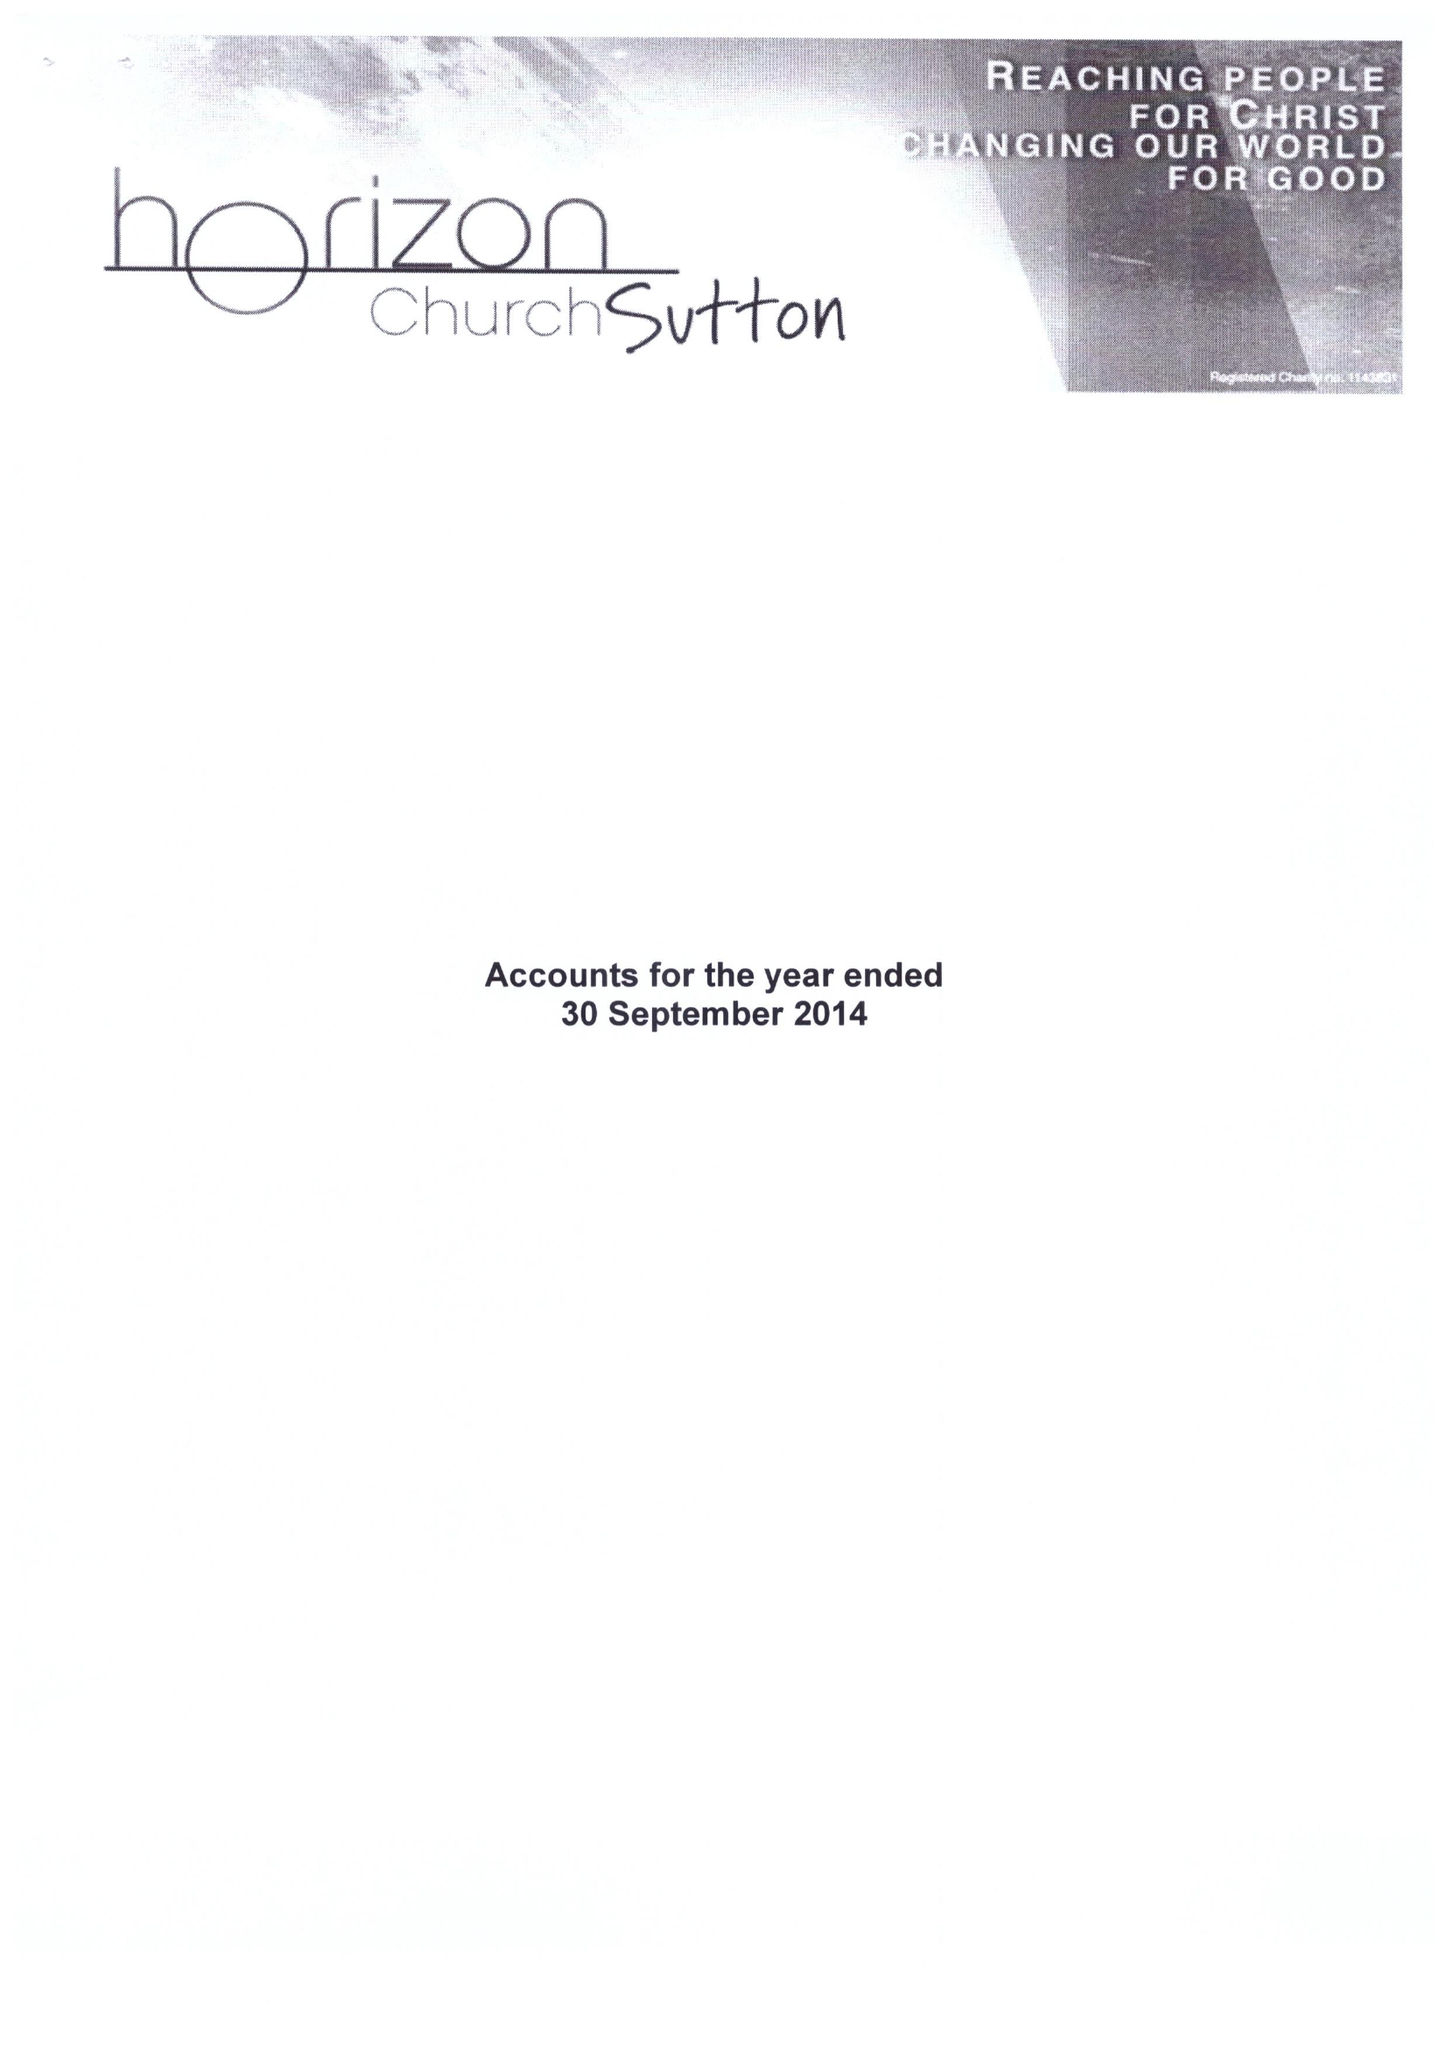What is the value for the spending_annually_in_british_pounds?
Answer the question using a single word or phrase. 92047.00 